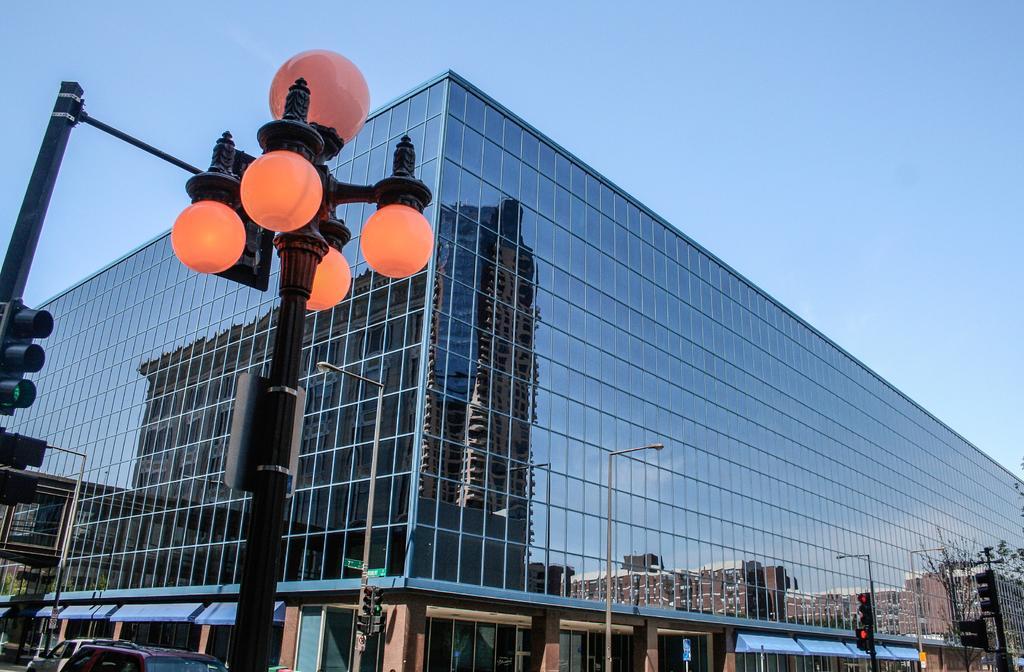Can you describe this image briefly? This image is taken outdoors. At the top of the image there is a sky. On the left side of the image there is a signal light and there is a street light. Two cars are parked on the road. In the middle of the image there is a building and there are a few street lights and signal lights. On the right side of the image there is a tree. 